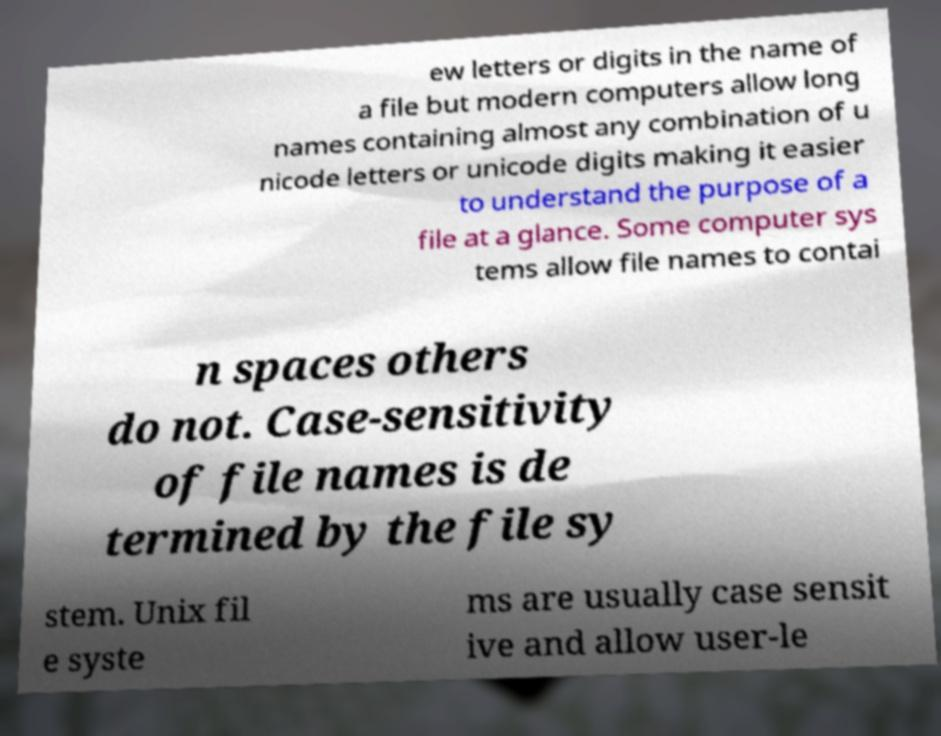Please identify and transcribe the text found in this image. ew letters or digits in the name of a file but modern computers allow long names containing almost any combination of u nicode letters or unicode digits making it easier to understand the purpose of a file at a glance. Some computer sys tems allow file names to contai n spaces others do not. Case-sensitivity of file names is de termined by the file sy stem. Unix fil e syste ms are usually case sensit ive and allow user-le 